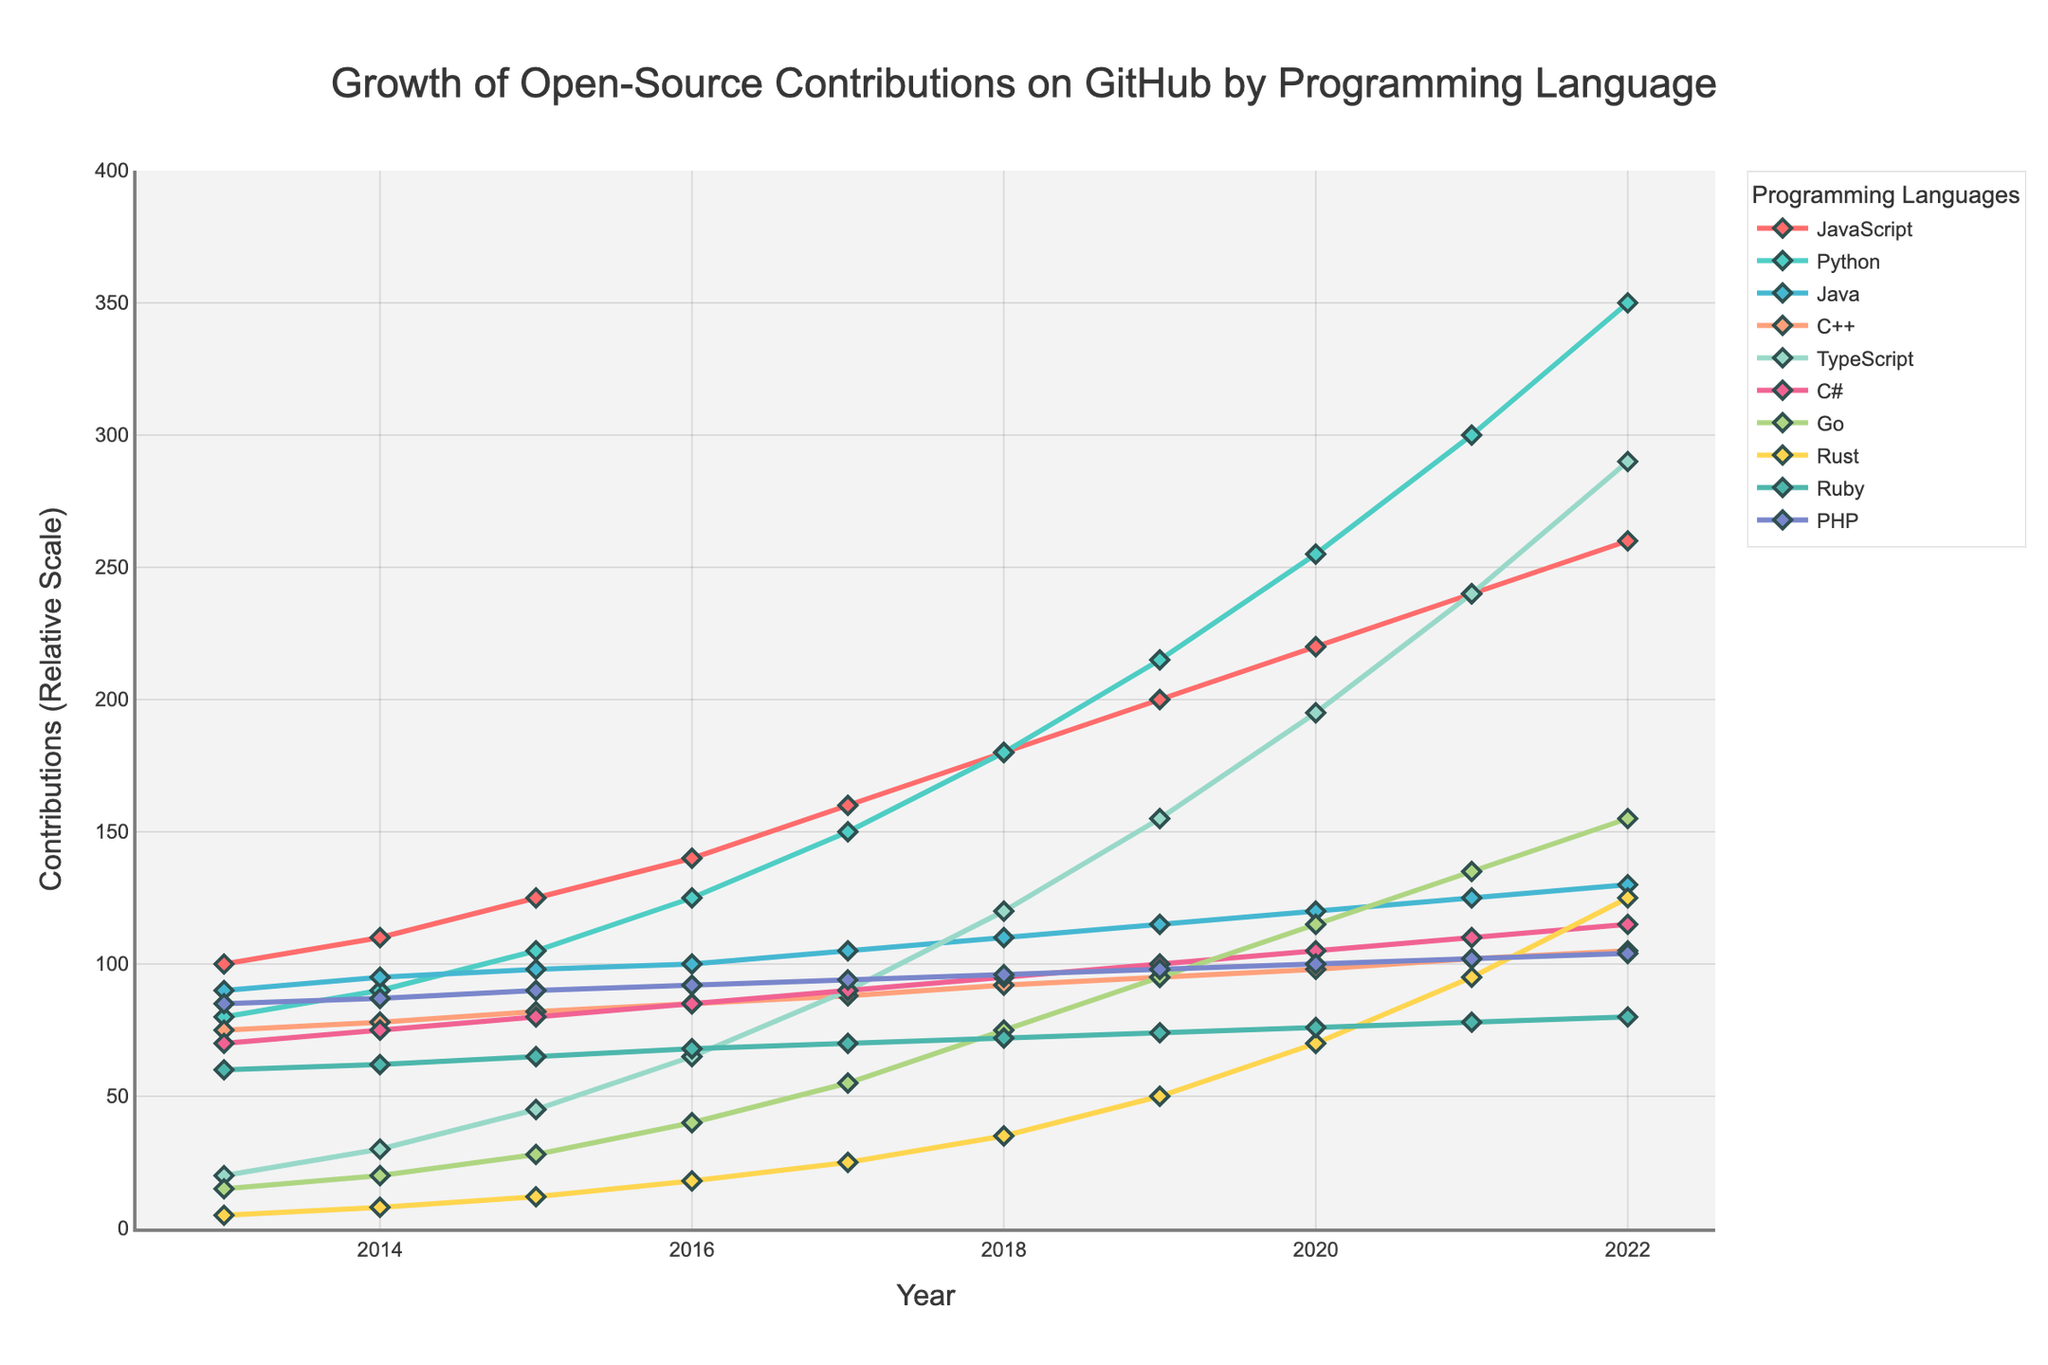What's the highest number of contributions made for any programming language in 2022? To find the highest number of contributions in 2022, compare the contributions of all languages in that year. The highest number observed is for Python with 350 contributions.
Answer: 350 Which programming language had the least growth in contributions from 2013 to 2022? To determine the least growth, calculate the difference in contributions from 2022 and 2013 for each language. C++ grew from 75 to 105, an increase of 30 contributions, which is the smallest growth among all the listed languages.
Answer: C++ How many more contributions were made to JavaScript than to PHP in 2016? For 2016, subtract the contributions of PHP from JavaScript: 140 (JavaScript) - 92 (PHP) = 48.
Answer: 48 Which programming language had the steepest increase in contributions between 2018 and 2019? To find the steepest increase, calculate the difference between the contributions in 2019 and 2018 for each language. TypeScript increased from 120 to 155, a difference of 35, which is the largest increase in that period.
Answer: TypeScript What is the average number of contributions for Python from 2013 to 2022? Sum the contributions of Python for each year from 2013 to 2022 and divide by the number of years (10). (80 + 90 + 105 + 125 + 150 + 180 + 215 + 255 + 300 + 350) = 1850. Average = 1850 / 10 = 185.
Answer: 185 Between which two consecutive years did Go see the highest increase in contributions? Calculate the difference in contributions for Go between consecutive years. The largest difference is between 2017 and 2018 where contributions increased from 55 to 75, a difference of 20.
Answer: 2017-2018 How did the contributions for Rust change from 2015 to 2016? Subtract the contributions for Rust in 2015 from those in 2016: 18 (2016) - 12 (2015) = 6.
Answer: Increased by 6 Which programming language had the second highest number of contributions in 2020? Compare the contributions of all languages in 2020. Python had the highest (255), and TypeScript had the second highest with 195 contributions.
Answer: TypeScript What is the total increase in contributions for Ruby from 2013 to 2022? Subtract the contributions for Ruby in 2013 from those in 2022: 80 (2022) - 60 (2013) = 20
Answer: 20 In which year did C# first surpass 100 contributions? Identify the first year among the listed years where C# has more than 100 contributions. In 2020, C# contributions were 105, marking the first time it surpassed 100.
Answer: 2020 